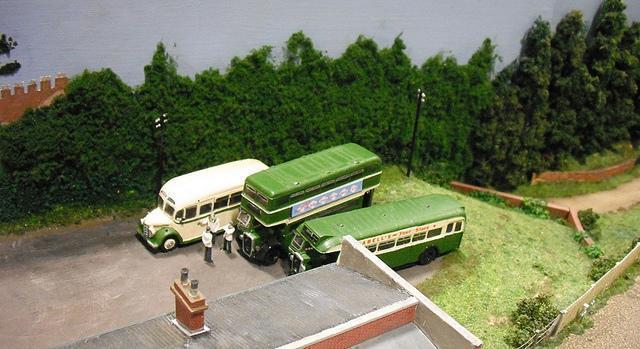How many buses?
Give a very brief answer. 3. How many buses are visible?
Give a very brief answer. 3. How many black cats are there?
Give a very brief answer. 0. 